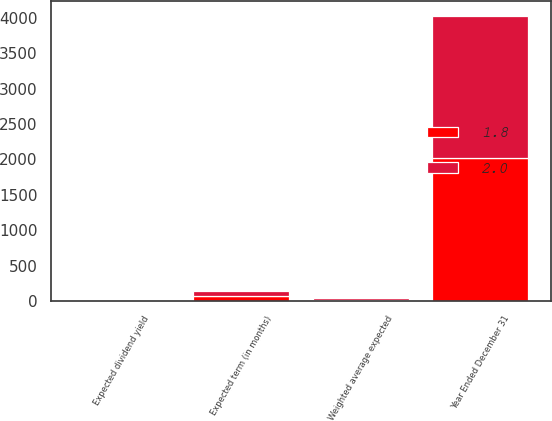<chart> <loc_0><loc_0><loc_500><loc_500><stacked_bar_chart><ecel><fcel>Year Ended December 31<fcel>Weighted average expected<fcel>Expected term (in months)<fcel>Expected dividend yield<nl><fcel>2<fcel>2017<fcel>19.4<fcel>68<fcel>1.8<nl><fcel>1.8<fcel>2016<fcel>20<fcel>70<fcel>2<nl></chart> 